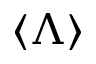<formula> <loc_0><loc_0><loc_500><loc_500>\langle \Lambda \rangle</formula> 